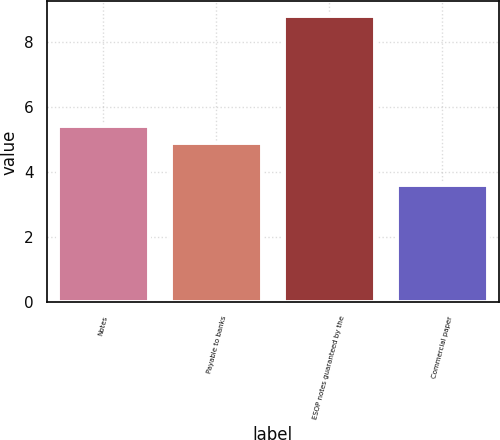Convert chart. <chart><loc_0><loc_0><loc_500><loc_500><bar_chart><fcel>Notes<fcel>Payable to banks<fcel>ESOP notes guaranteed by the<fcel>Commercial paper<nl><fcel>5.42<fcel>4.9<fcel>8.8<fcel>3.6<nl></chart> 